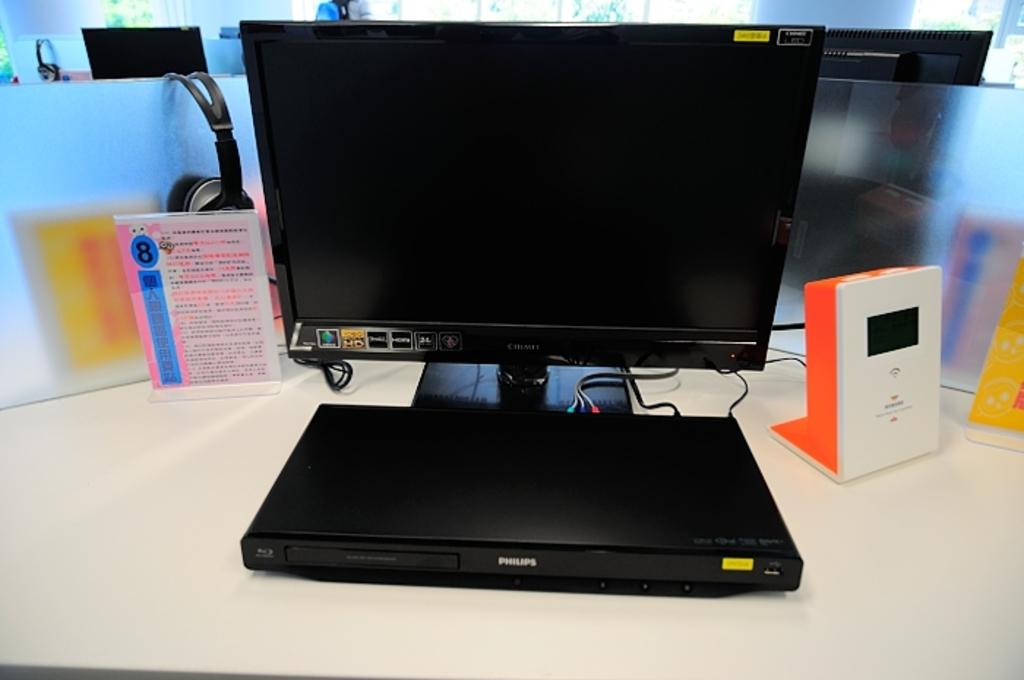What can be observed about the background of the image? The background of the image is blurred. What type of equipment is present in the image? There are monitors, headsets, boards, and devices in the image. Can you describe the objects in the image? There are objects in the image, but their specific nature is not clear due to the blurred background. What type of insurance policy is being discussed in the image? There is no indication of an insurance policy or discussion about one in the image. How many pages are visible in the image? There are no pages visible in the image; it is not a photograph of a document or book. 